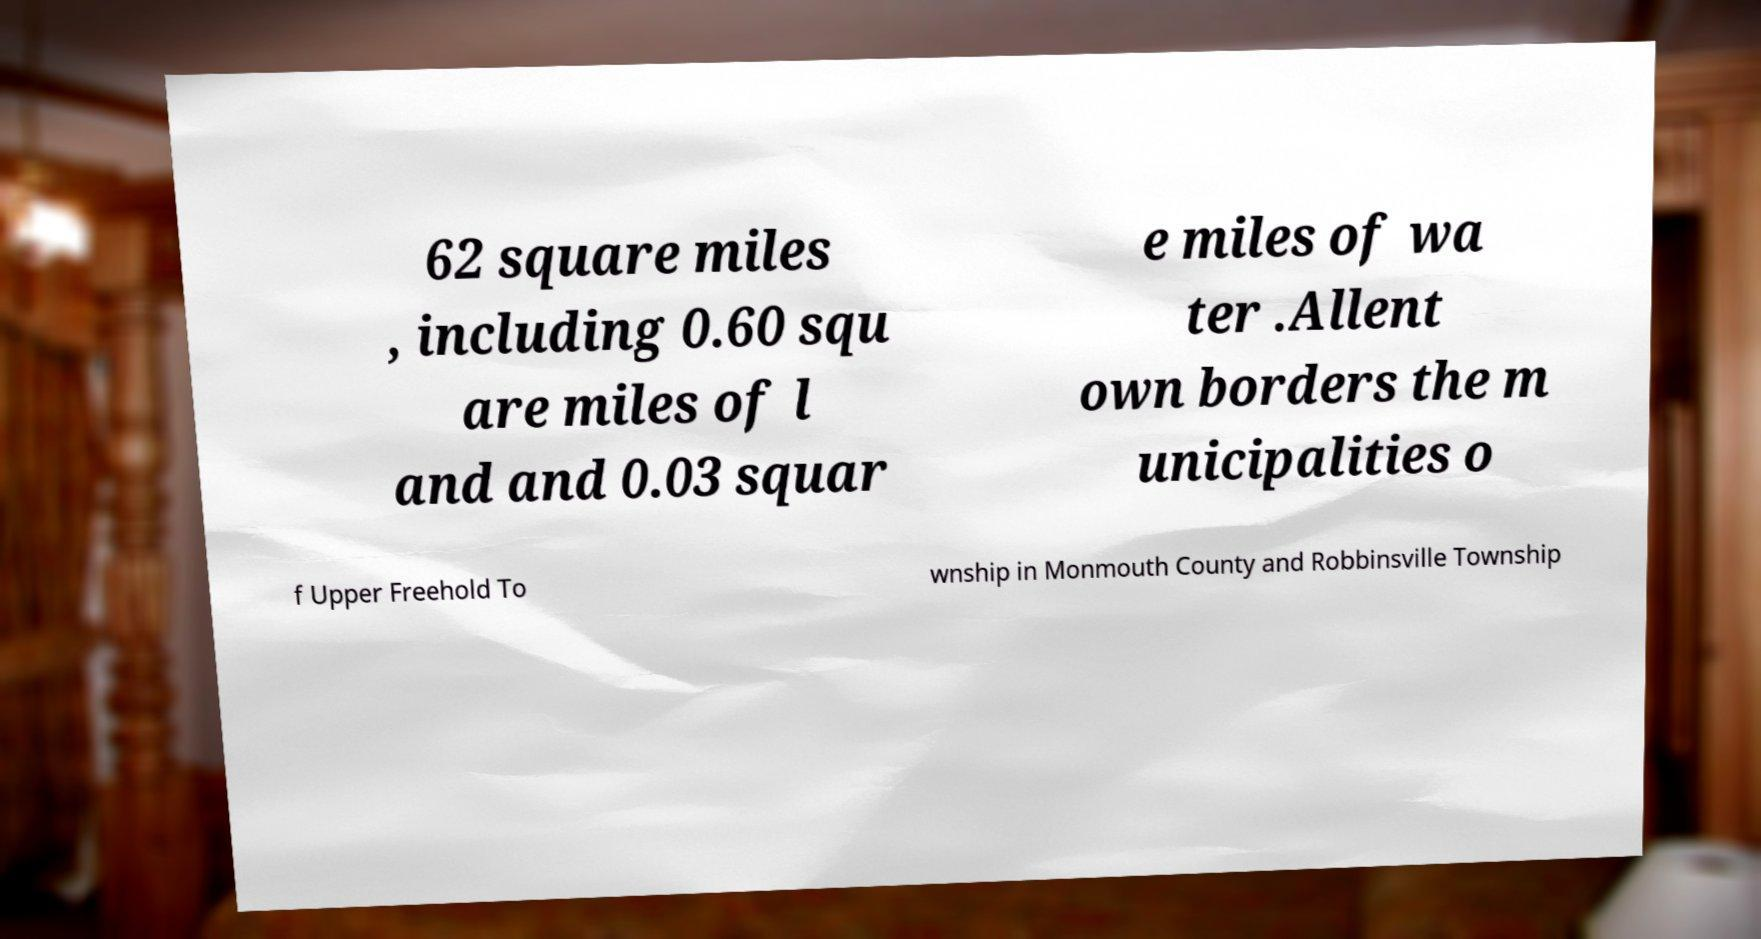For documentation purposes, I need the text within this image transcribed. Could you provide that? 62 square miles , including 0.60 squ are miles of l and and 0.03 squar e miles of wa ter .Allent own borders the m unicipalities o f Upper Freehold To wnship in Monmouth County and Robbinsville Township 